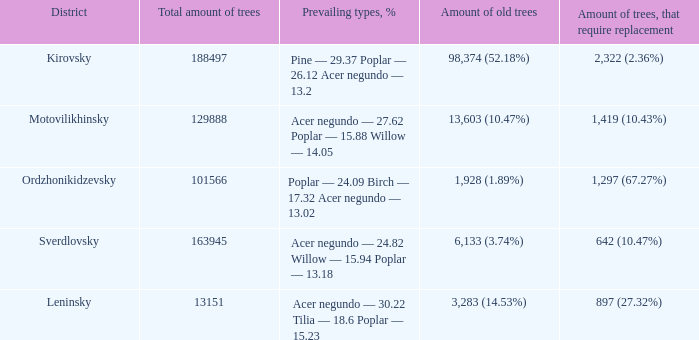89%)? Ordzhonikidzevsky. 